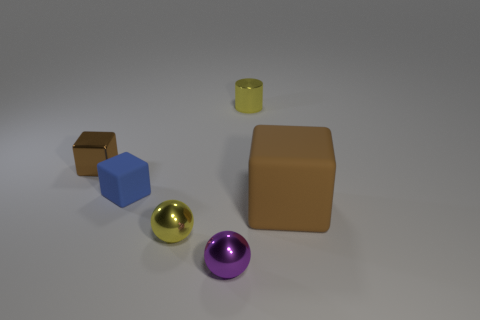Add 3 metal cylinders. How many objects exist? 9 Subtract all balls. How many objects are left? 4 Add 2 blue matte blocks. How many blue matte blocks exist? 3 Subtract 0 blue cylinders. How many objects are left? 6 Subtract all big rubber cubes. Subtract all metallic blocks. How many objects are left? 4 Add 5 blocks. How many blocks are left? 8 